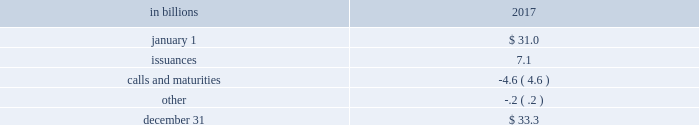60 the pnc financial services group , inc .
2013 form 10-k liquidity and capital management liquidity risk has two fundamental components .
The first is potential loss assuming we were unable to meet our funding requirements at a reasonable cost .
The second is the potential inability to operate our businesses because adequate contingent liquidity is not available .
We manage liquidity risk at the consolidated company level ( bank , parent company , and nonbank subsidiaries combined ) to help ensure that we can obtain cost-effective funding to meet current and future obligations under both normal 201cbusiness as usual 201d and stressful circumstances , and to help ensure that we maintain an appropriate level of contingent liquidity .
Management monitors liquidity through a series of early warning indicators that may indicate a potential market , or pnc-specific , liquidity stress event .
In addition , management performs a set of liquidity stress tests over multiple time horizons with varying levels of severity and maintains a contingency funding plan to address a potential liquidity stress event .
In the most severe liquidity stress simulation , we assume that our liquidity position is under pressure , while the market in general is under systemic pressure .
The simulation considers , among other things , the impact of restricted access to both secured and unsecured external sources of funding , accelerated run-off of customer deposits , valuation pressure on assets and heavy demand to fund committed obligations .
Parent company liquidity guidelines are designed to help ensure that sufficient liquidity is available to meet our parent company obligations over the succeeding 24-month period .
Liquidity-related risk limits are established within our enterprise liquidity management policy and supporting policies .
Management committees , including the asset and liability committee , and the board of directors and its risk committee regularly review compliance with key established limits .
In addition to these liquidity monitoring measures and tools described above , we also monitor our liquidity by reference to the liquidity coverage ratio ( lcr ) which is further described in the supervision and regulation section in item 1 of this report .
Pnc and pnc bank calculate the lcr on a daily basis and as of december 31 , 2017 , the lcr for pnc and pnc bank exceeded the fully phased-in requirement of we provide additional information regarding regulatory liquidity requirements and their potential impact on us in the supervision and regulation section of item 1 business and item 1a risk factors of this report .
Sources of liquidity our largest source of liquidity on a consolidated basis is the customer deposit base generated by our banking businesses .
These deposits provide relatively stable and low-cost funding .
Total deposits increased to $ 265.1 billion at december 31 , 2017 from $ 257.2 billion at december 31 , 2016 , driven by higher consumer and commercial deposits .
Consumer deposits reflected in part a shift from money market deposits to relationship-based savings products .
Commercial deposits reflected a shift from demand deposits to money market deposits primarily due to higher interest rates in 2017 .
Additionally , certain assets determined by us to be liquid and unused borrowing capacity from a number of sources are also available to manage our liquidity position .
At december 31 , 2017 , our liquid assets consisted of short- term investments ( federal funds sold , resale agreements , trading securities and interest-earning deposits with banks ) totaling $ 33.0 billion and securities available for sale totaling $ 57.6 billion .
The level of liquid assets fluctuates over time based on many factors , including market conditions , loan and deposit growth and balance sheet management activities .
Of our total liquid assets of $ 90.6 billion , we had $ 3.2 billion of securities available for sale and trading securities pledged as collateral to secure public and trust deposits , repurchase agreements and for other purposes .
In addition , $ 4.9 billion of securities held to maturity were also pledged as collateral for these purposes .
We also obtain liquidity through various forms of funding , including long-term debt ( senior notes , subordinated debt and fhlb advances ) and short-term borrowings ( securities sold under repurchase agreements , commercial paper and other short-term borrowings ) .
See note 10 borrowed funds and the funding sources section of the consolidated balance sheet review in this report for additional information related to our borrowings .
Total senior and subordinated debt , on a consolidated basis , increased due to the following activity : table 25 : senior and subordinated debt .

2017 ending total liquid assets were what percent of total senior and subordinated debt? 
Computations: (90.6 / 33.3)
Answer: 2.72072. 60 the pnc financial services group , inc .
2013 form 10-k liquidity and capital management liquidity risk has two fundamental components .
The first is potential loss assuming we were unable to meet our funding requirements at a reasonable cost .
The second is the potential inability to operate our businesses because adequate contingent liquidity is not available .
We manage liquidity risk at the consolidated company level ( bank , parent company , and nonbank subsidiaries combined ) to help ensure that we can obtain cost-effective funding to meet current and future obligations under both normal 201cbusiness as usual 201d and stressful circumstances , and to help ensure that we maintain an appropriate level of contingent liquidity .
Management monitors liquidity through a series of early warning indicators that may indicate a potential market , or pnc-specific , liquidity stress event .
In addition , management performs a set of liquidity stress tests over multiple time horizons with varying levels of severity and maintains a contingency funding plan to address a potential liquidity stress event .
In the most severe liquidity stress simulation , we assume that our liquidity position is under pressure , while the market in general is under systemic pressure .
The simulation considers , among other things , the impact of restricted access to both secured and unsecured external sources of funding , accelerated run-off of customer deposits , valuation pressure on assets and heavy demand to fund committed obligations .
Parent company liquidity guidelines are designed to help ensure that sufficient liquidity is available to meet our parent company obligations over the succeeding 24-month period .
Liquidity-related risk limits are established within our enterprise liquidity management policy and supporting policies .
Management committees , including the asset and liability committee , and the board of directors and its risk committee regularly review compliance with key established limits .
In addition to these liquidity monitoring measures and tools described above , we also monitor our liquidity by reference to the liquidity coverage ratio ( lcr ) which is further described in the supervision and regulation section in item 1 of this report .
Pnc and pnc bank calculate the lcr on a daily basis and as of december 31 , 2017 , the lcr for pnc and pnc bank exceeded the fully phased-in requirement of we provide additional information regarding regulatory liquidity requirements and their potential impact on us in the supervision and regulation section of item 1 business and item 1a risk factors of this report .
Sources of liquidity our largest source of liquidity on a consolidated basis is the customer deposit base generated by our banking businesses .
These deposits provide relatively stable and low-cost funding .
Total deposits increased to $ 265.1 billion at december 31 , 2017 from $ 257.2 billion at december 31 , 2016 , driven by higher consumer and commercial deposits .
Consumer deposits reflected in part a shift from money market deposits to relationship-based savings products .
Commercial deposits reflected a shift from demand deposits to money market deposits primarily due to higher interest rates in 2017 .
Additionally , certain assets determined by us to be liquid and unused borrowing capacity from a number of sources are also available to manage our liquidity position .
At december 31 , 2017 , our liquid assets consisted of short- term investments ( federal funds sold , resale agreements , trading securities and interest-earning deposits with banks ) totaling $ 33.0 billion and securities available for sale totaling $ 57.6 billion .
The level of liquid assets fluctuates over time based on many factors , including market conditions , loan and deposit growth and balance sheet management activities .
Of our total liquid assets of $ 90.6 billion , we had $ 3.2 billion of securities available for sale and trading securities pledged as collateral to secure public and trust deposits , repurchase agreements and for other purposes .
In addition , $ 4.9 billion of securities held to maturity were also pledged as collateral for these purposes .
We also obtain liquidity through various forms of funding , including long-term debt ( senior notes , subordinated debt and fhlb advances ) and short-term borrowings ( securities sold under repurchase agreements , commercial paper and other short-term borrowings ) .
See note 10 borrowed funds and the funding sources section of the consolidated balance sheet review in this report for additional information related to our borrowings .
Total senior and subordinated debt , on a consolidated basis , increased due to the following activity : table 25 : senior and subordinated debt .

What was the total of of securities available for sale and trading securities pledged as collateral to secure public and trust deposits , repurchase agreements and securities held to maturity pledged as collateral for these purposes for 2017 in billions? 
Computations: (3.2 + 4.9)
Answer: 8.1. 